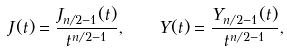<formula> <loc_0><loc_0><loc_500><loc_500>J ( t ) = \frac { J _ { n / 2 - 1 } ( t ) } { t ^ { n / 2 - 1 } } , \quad Y ( t ) = \frac { Y _ { n / 2 - 1 } ( t ) } { t ^ { n / 2 - 1 } } ,</formula> 